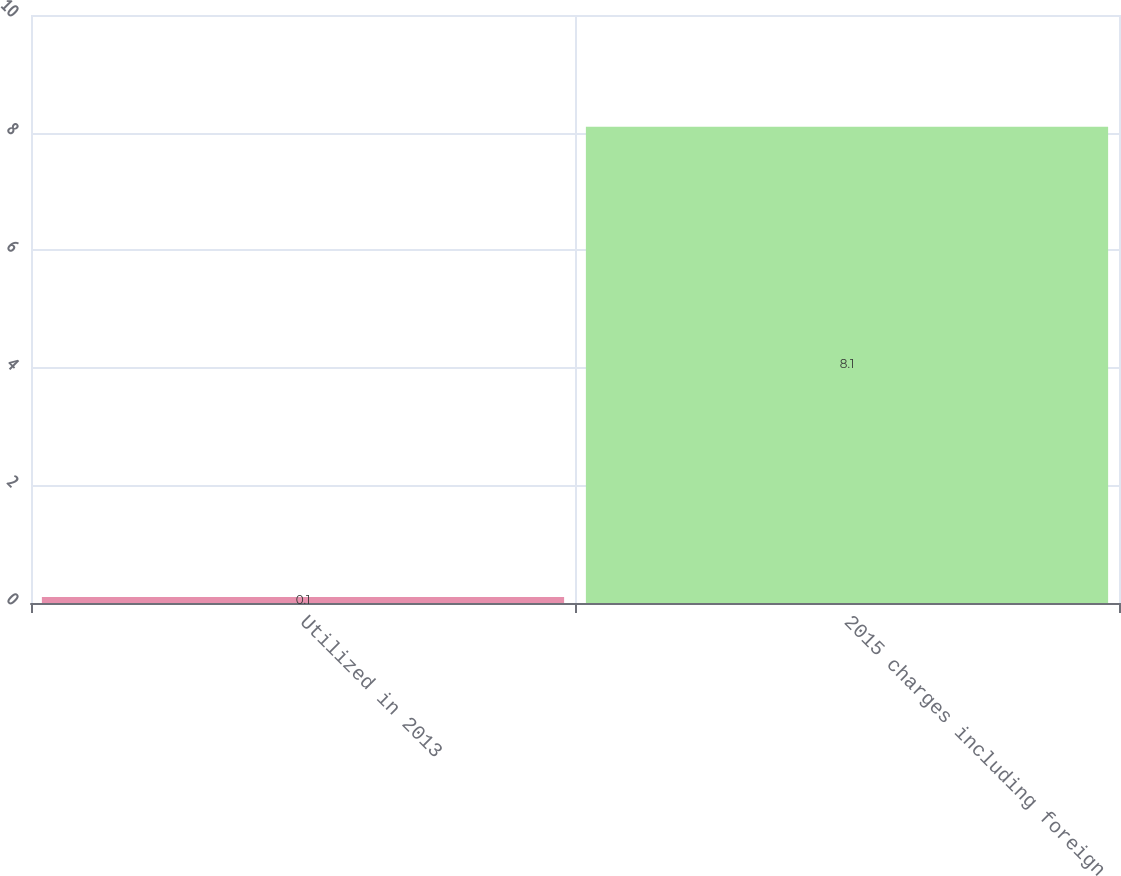<chart> <loc_0><loc_0><loc_500><loc_500><bar_chart><fcel>Utilized in 2013<fcel>2015 charges including foreign<nl><fcel>0.1<fcel>8.1<nl></chart> 